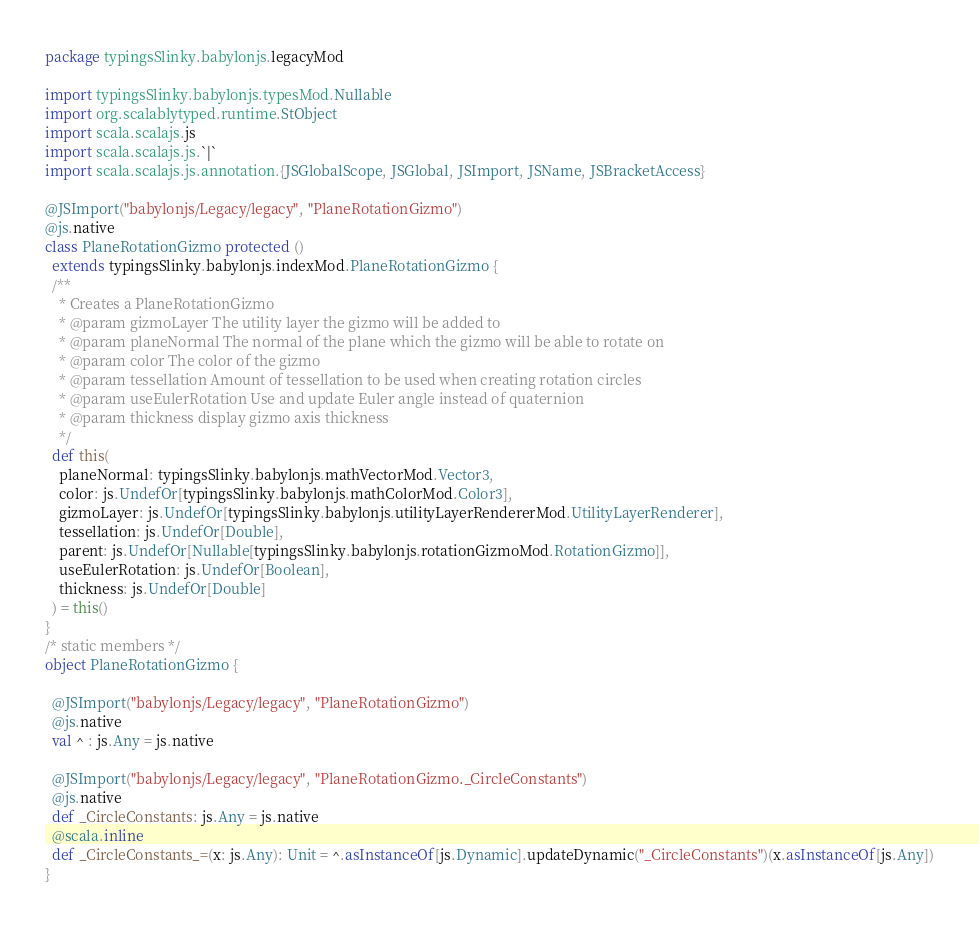Convert code to text. <code><loc_0><loc_0><loc_500><loc_500><_Scala_>package typingsSlinky.babylonjs.legacyMod

import typingsSlinky.babylonjs.typesMod.Nullable
import org.scalablytyped.runtime.StObject
import scala.scalajs.js
import scala.scalajs.js.`|`
import scala.scalajs.js.annotation.{JSGlobalScope, JSGlobal, JSImport, JSName, JSBracketAccess}

@JSImport("babylonjs/Legacy/legacy", "PlaneRotationGizmo")
@js.native
class PlaneRotationGizmo protected ()
  extends typingsSlinky.babylonjs.indexMod.PlaneRotationGizmo {
  /**
    * Creates a PlaneRotationGizmo
    * @param gizmoLayer The utility layer the gizmo will be added to
    * @param planeNormal The normal of the plane which the gizmo will be able to rotate on
    * @param color The color of the gizmo
    * @param tessellation Amount of tessellation to be used when creating rotation circles
    * @param useEulerRotation Use and update Euler angle instead of quaternion
    * @param thickness display gizmo axis thickness
    */
  def this(
    planeNormal: typingsSlinky.babylonjs.mathVectorMod.Vector3,
    color: js.UndefOr[typingsSlinky.babylonjs.mathColorMod.Color3],
    gizmoLayer: js.UndefOr[typingsSlinky.babylonjs.utilityLayerRendererMod.UtilityLayerRenderer],
    tessellation: js.UndefOr[Double],
    parent: js.UndefOr[Nullable[typingsSlinky.babylonjs.rotationGizmoMod.RotationGizmo]],
    useEulerRotation: js.UndefOr[Boolean],
    thickness: js.UndefOr[Double]
  ) = this()
}
/* static members */
object PlaneRotationGizmo {
  
  @JSImport("babylonjs/Legacy/legacy", "PlaneRotationGizmo")
  @js.native
  val ^ : js.Any = js.native
  
  @JSImport("babylonjs/Legacy/legacy", "PlaneRotationGizmo._CircleConstants")
  @js.native
  def _CircleConstants: js.Any = js.native
  @scala.inline
  def _CircleConstants_=(x: js.Any): Unit = ^.asInstanceOf[js.Dynamic].updateDynamic("_CircleConstants")(x.asInstanceOf[js.Any])
}
</code> 